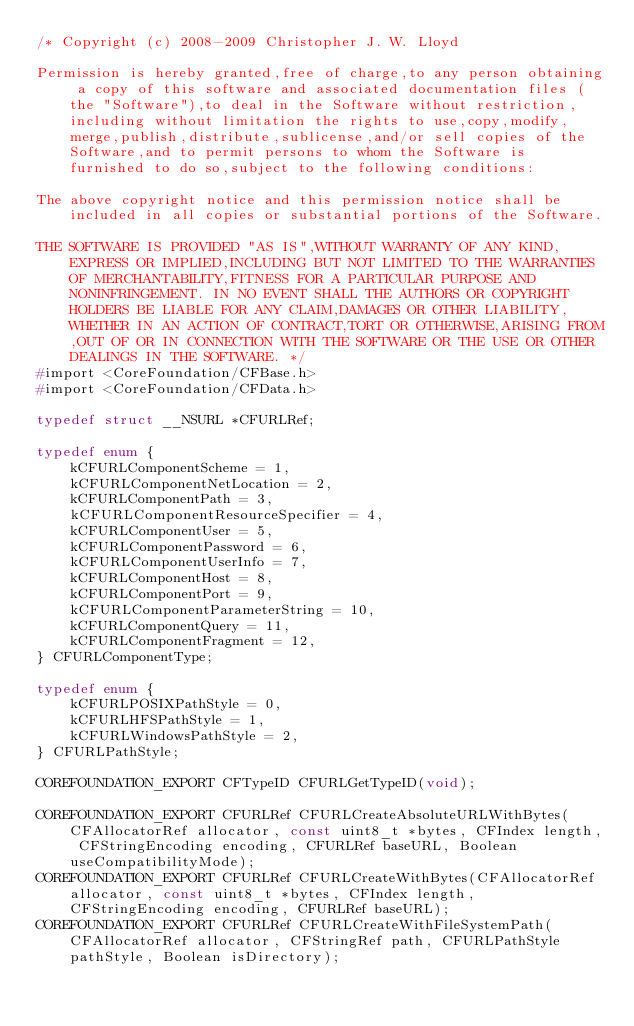Convert code to text. <code><loc_0><loc_0><loc_500><loc_500><_C_>/* Copyright (c) 2008-2009 Christopher J. W. Lloyd

Permission is hereby granted,free of charge,to any person obtaining a copy of this software and associated documentation files (the "Software"),to deal in the Software without restriction,including without limitation the rights to use,copy,modify,merge,publish,distribute,sublicense,and/or sell copies of the Software,and to permit persons to whom the Software is furnished to do so,subject to the following conditions:

The above copyright notice and this permission notice shall be included in all copies or substantial portions of the Software.

THE SOFTWARE IS PROVIDED "AS IS",WITHOUT WARRANTY OF ANY KIND,EXPRESS OR IMPLIED,INCLUDING BUT NOT LIMITED TO THE WARRANTIES OF MERCHANTABILITY,FITNESS FOR A PARTICULAR PURPOSE AND NONINFRINGEMENT. IN NO EVENT SHALL THE AUTHORS OR COPYRIGHT HOLDERS BE LIABLE FOR ANY CLAIM,DAMAGES OR OTHER LIABILITY,WHETHER IN AN ACTION OF CONTRACT,TORT OR OTHERWISE,ARISING FROM,OUT OF OR IN CONNECTION WITH THE SOFTWARE OR THE USE OR OTHER DEALINGS IN THE SOFTWARE. */
#import <CoreFoundation/CFBase.h>
#import <CoreFoundation/CFData.h>

typedef struct __NSURL *CFURLRef;

typedef enum {
    kCFURLComponentScheme = 1,
    kCFURLComponentNetLocation = 2,
    kCFURLComponentPath = 3,
    kCFURLComponentResourceSpecifier = 4,
    kCFURLComponentUser = 5,
    kCFURLComponentPassword = 6,
    kCFURLComponentUserInfo = 7,
    kCFURLComponentHost = 8,
    kCFURLComponentPort = 9,
    kCFURLComponentParameterString = 10,
    kCFURLComponentQuery = 11,
    kCFURLComponentFragment = 12,
} CFURLComponentType;

typedef enum {
    kCFURLPOSIXPathStyle = 0,
    kCFURLHFSPathStyle = 1,
    kCFURLWindowsPathStyle = 2,
} CFURLPathStyle;

COREFOUNDATION_EXPORT CFTypeID CFURLGetTypeID(void);

COREFOUNDATION_EXPORT CFURLRef CFURLCreateAbsoluteURLWithBytes(CFAllocatorRef allocator, const uint8_t *bytes, CFIndex length, CFStringEncoding encoding, CFURLRef baseURL, Boolean useCompatibilityMode);
COREFOUNDATION_EXPORT CFURLRef CFURLCreateWithBytes(CFAllocatorRef allocator, const uint8_t *bytes, CFIndex length, CFStringEncoding encoding, CFURLRef baseURL);
COREFOUNDATION_EXPORT CFURLRef CFURLCreateWithFileSystemPath(CFAllocatorRef allocator, CFStringRef path, CFURLPathStyle pathStyle, Boolean isDirectory);</code> 